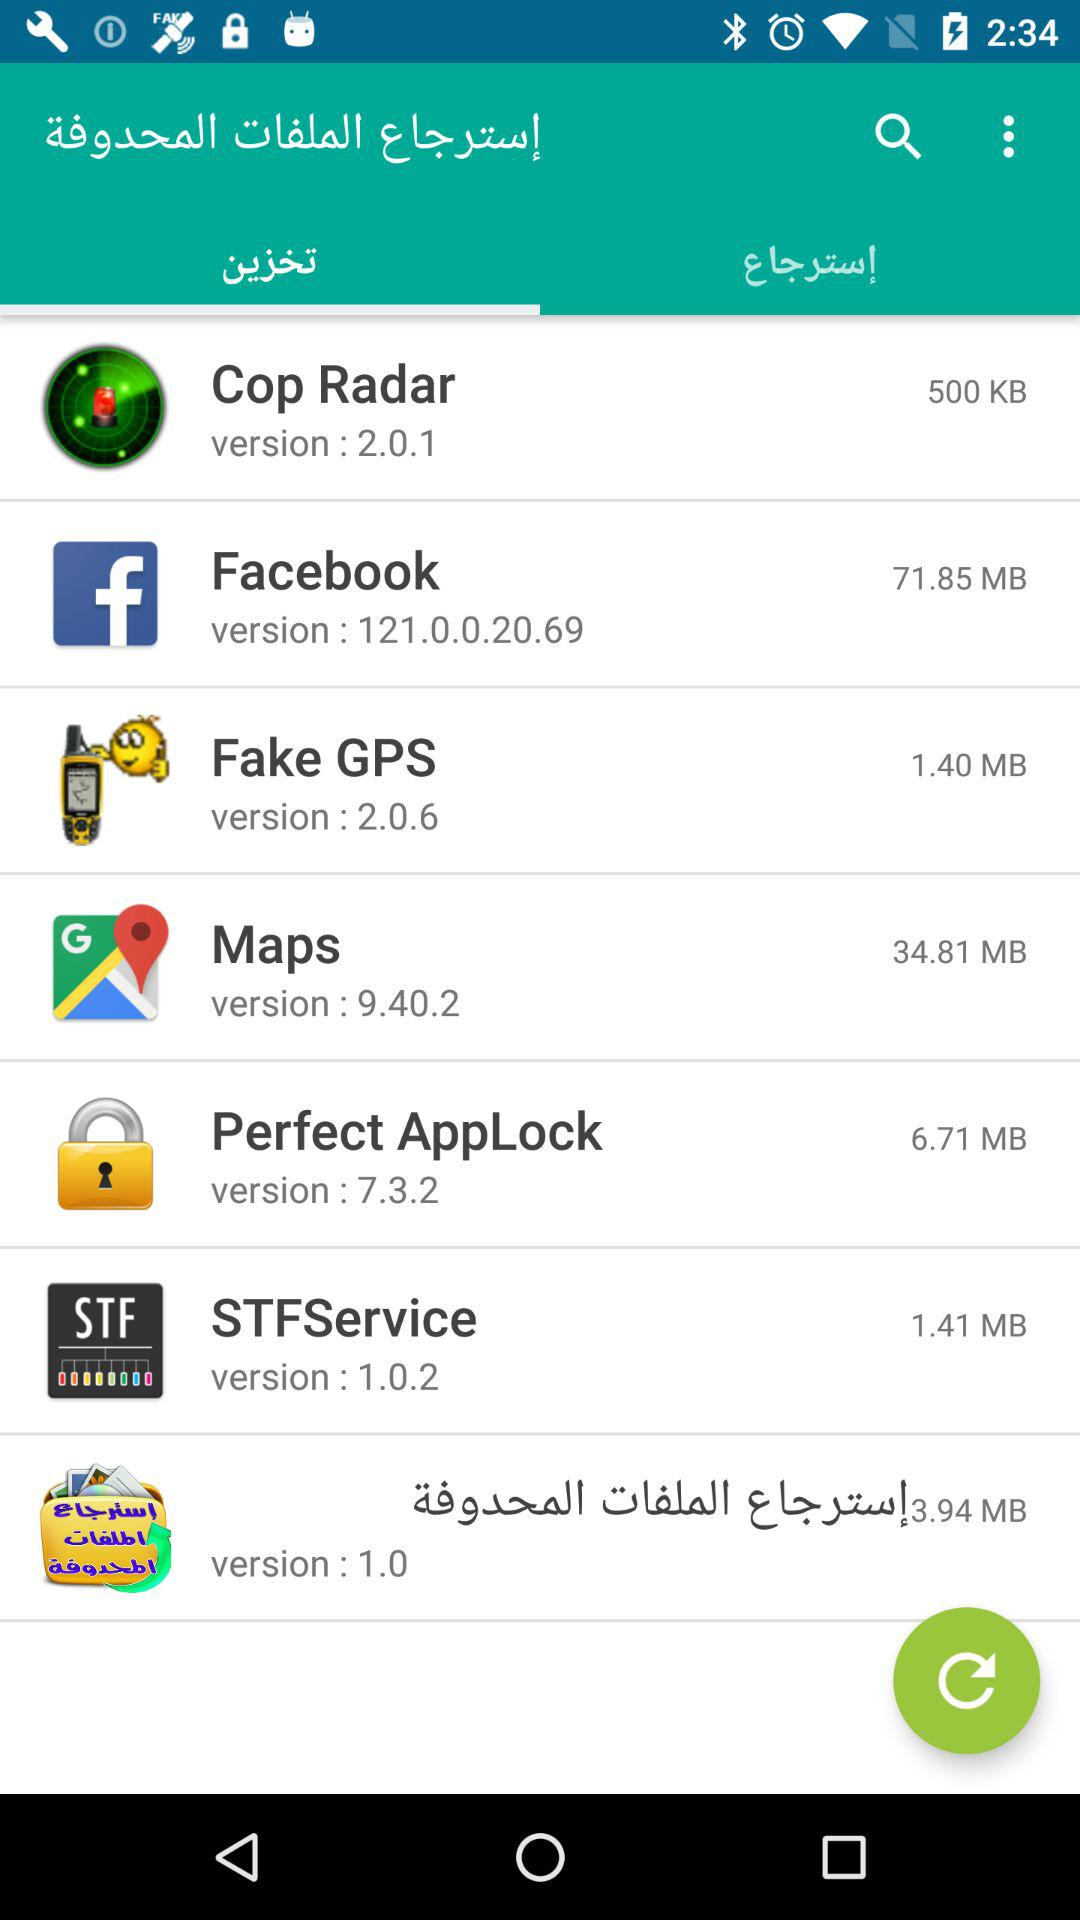What is the version of "Maps"? The version is 9.40.2. 